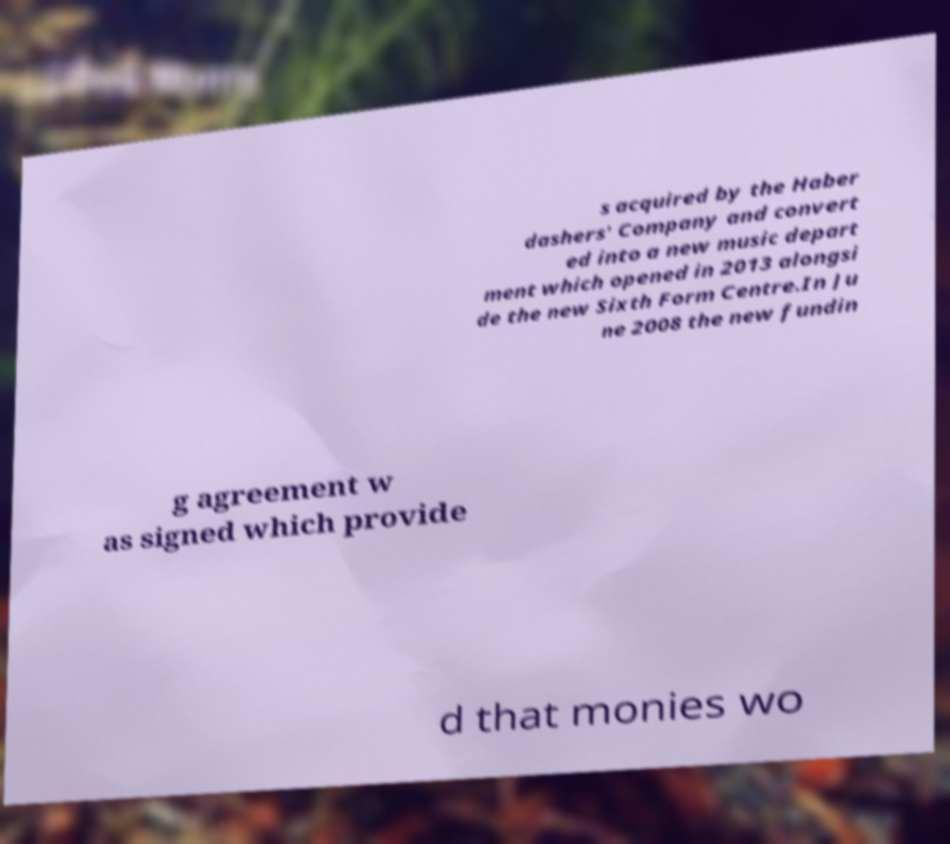What messages or text are displayed in this image? I need them in a readable, typed format. s acquired by the Haber dashers' Company and convert ed into a new music depart ment which opened in 2013 alongsi de the new Sixth Form Centre.In Ju ne 2008 the new fundin g agreement w as signed which provide d that monies wo 